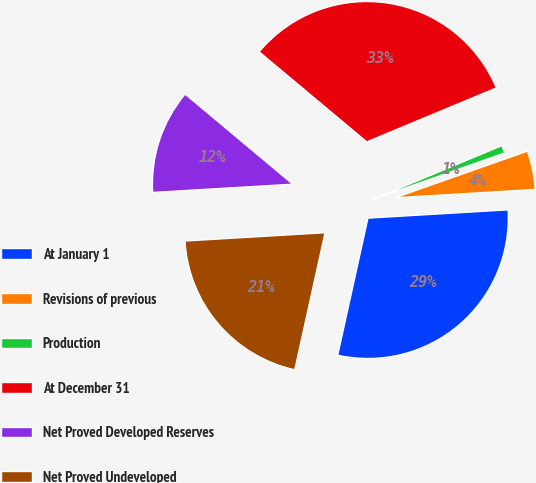Convert chart. <chart><loc_0><loc_0><loc_500><loc_500><pie_chart><fcel>At January 1<fcel>Revisions of previous<fcel>Production<fcel>At December 31<fcel>Net Proved Developed Reserves<fcel>Net Proved Undeveloped<nl><fcel>29.4%<fcel>4.45%<fcel>0.89%<fcel>32.63%<fcel>12.03%<fcel>20.6%<nl></chart> 